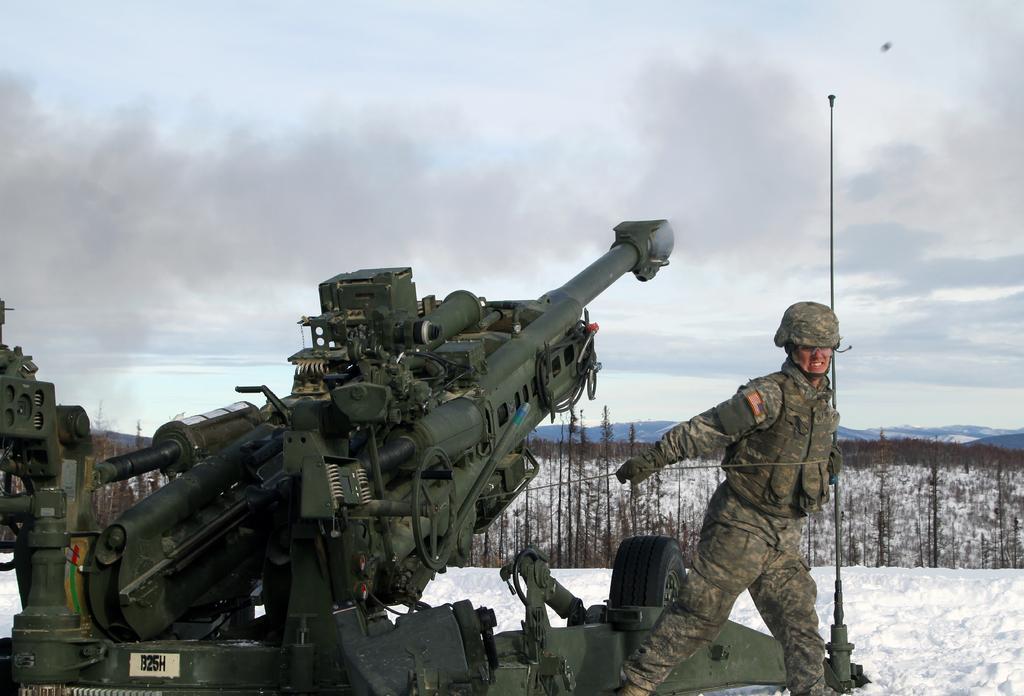Could you give a brief overview of what you see in this image? In this picture I can see an military equipment in front and near to it I can see a person wearing army uniform. In the background I can see the snow, few plants, mountains and the sky. 